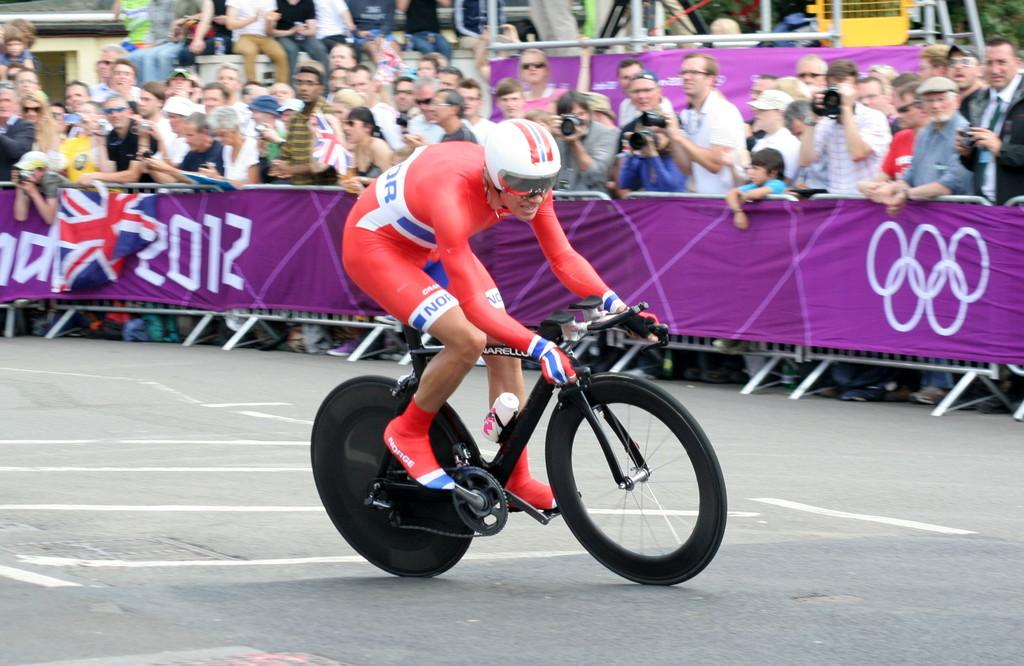What is the main subject in the foreground of the image? There is a person riding a bicycle in the foreground of the image. What safety precaution is the person taking while riding the bicycle? The person is wearing a helmet. What are the people in the background of the image doing? In the background of the image, there are many people standing, and some of them are taking pictures. What type of rule does the wren follow while riding the bicycle in the image? There is no wren present in the image, and therefore no rules for it to follow. 